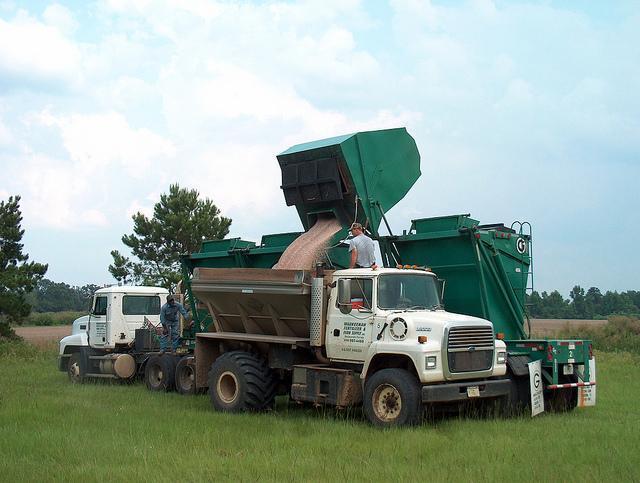How many people are in the picture?
Give a very brief answer. 2. How many trucks are there?
Give a very brief answer. 2. 